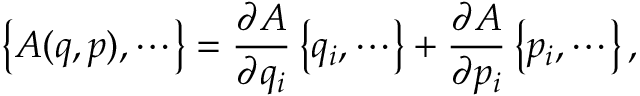Convert formula to latex. <formula><loc_0><loc_0><loc_500><loc_500>\left \{ A ( q , p ) , \cdots \right \} = \frac { \partial A } { \partial q _ { i } } \, \left \{ q _ { i } , \cdots \right \} + \frac { \partial A } { \partial p _ { i } } \, \left \{ p _ { i } , \cdots \right \} \, ,</formula> 